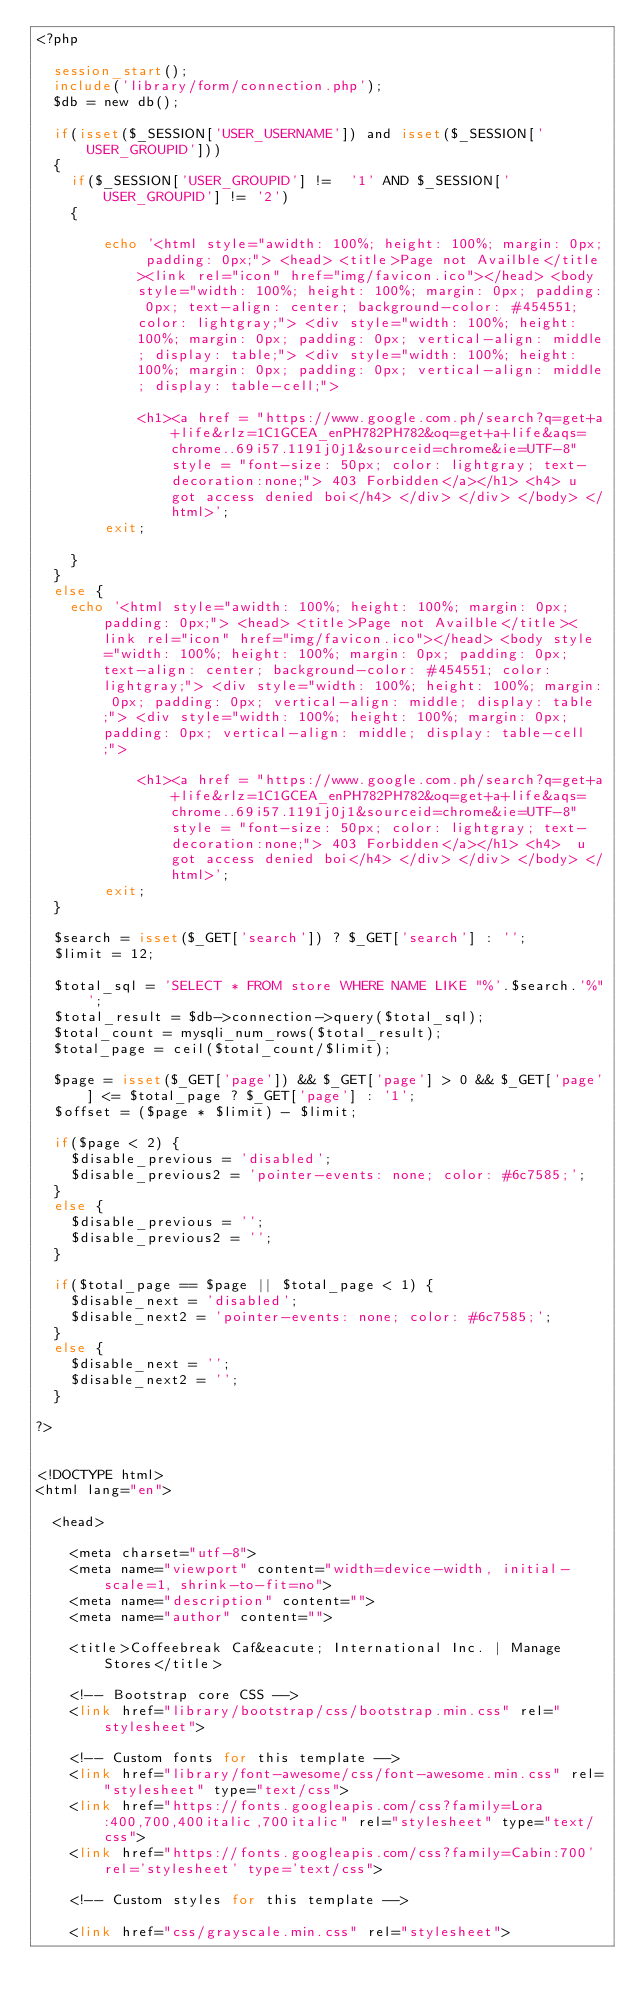Convert code to text. <code><loc_0><loc_0><loc_500><loc_500><_PHP_><?php
	
	session_start();
	include('library/form/connection.php');
	$db = new db();
	
	if(isset($_SESSION['USER_USERNAME']) and isset($_SESSION['USER_GROUPID']))
	{
		if($_SESSION['USER_GROUPID'] !=  '1' AND $_SESSION['USER_GROUPID'] != '2')
		{
			
        echo '<html style="awidth: 100%; height: 100%; margin: 0px; padding: 0px;"> <head> <title>Page not Availble</title><link rel="icon" href="img/favicon.ico"></head> <body style="width: 100%; height: 100%; margin: 0px; padding: 0px; text-align: center; background-color: #454551; color: lightgray;"> <div style="width: 100%; height: 100%; margin: 0px; padding: 0px; vertical-align: middle; display: table;"> <div style="width: 100%; height: 100%; margin: 0px; padding: 0px; vertical-align: middle; display: table-cell;"> 

            <h1><a href = "https://www.google.com.ph/search?q=get+a+life&rlz=1C1GCEA_enPH782PH782&oq=get+a+life&aqs=chrome..69i57.1191j0j1&sourceid=chrome&ie=UTF-8" style = "font-size: 50px; color: lightgray; text-decoration:none;"> 403 Forbidden</a></h1> <h4> u got access denied boi</h4> </div> </div> </body> </html>';
        exit;
   
		}
	}
	else {
		echo '<html style="awidth: 100%; height: 100%; margin: 0px; padding: 0px;"> <head> <title>Page not Availble</title><link rel="icon" href="img/favicon.ico"></head> <body style="width: 100%; height: 100%; margin: 0px; padding: 0px; text-align: center; background-color: #454551; color: lightgray;"> <div style="width: 100%; height: 100%; margin: 0px; padding: 0px; vertical-align: middle; display: table;"> <div style="width: 100%; height: 100%; margin: 0px; padding: 0px; vertical-align: middle; display: table-cell;"> 

            <h1><a href = "https://www.google.com.ph/search?q=get+a+life&rlz=1C1GCEA_enPH782PH782&oq=get+a+life&aqs=chrome..69i57.1191j0j1&sourceid=chrome&ie=UTF-8" style = "font-size: 50px; color: lightgray; text-decoration:none;"> 403 Forbidden</a></h1> <h4>  u got access denied boi</h4> </div> </div> </body> </html>';
        exit;
	}

	$search = isset($_GET['search']) ? $_GET['search'] : '';
	$limit = 12;

	$total_sql = 'SELECT * FROM store WHERE NAME LIKE "%'.$search.'%"';
	$total_result = $db->connection->query($total_sql);
	$total_count = mysqli_num_rows($total_result);
	$total_page = ceil($total_count/$limit);

	$page = isset($_GET['page']) && $_GET['page'] > 0 && $_GET['page'] <= $total_page ? $_GET['page'] : '1';
	$offset = ($page * $limit) - $limit;

	if($page < 2) {
		$disable_previous = 'disabled';
		$disable_previous2 = 'pointer-events: none; color: #6c7585;';
	}
	else {
		$disable_previous = '';
		$disable_previous2 = '';
	}

	if($total_page == $page || $total_page < 1) {
		$disable_next = 'disabled';
		$disable_next2 = 'pointer-events: none; color: #6c7585;';
	}
	else {
		$disable_next = '';
		$disable_next2 = '';
	}

?>


<!DOCTYPE html>
<html lang="en">

  <head>

    <meta charset="utf-8">
    <meta name="viewport" content="width=device-width, initial-scale=1, shrink-to-fit=no">
    <meta name="description" content="">
    <meta name="author" content="">

    <title>Coffeebreak Caf&eacute; International Inc. | Manage Stores</title>

    <!-- Bootstrap core CSS -->
    <link href="library/bootstrap/css/bootstrap.min.css" rel="stylesheet">
	 
    <!-- Custom fonts for this template -->
    <link href="library/font-awesome/css/font-awesome.min.css" rel="stylesheet" type="text/css">
    <link href="https://fonts.googleapis.com/css?family=Lora:400,700,400italic,700italic" rel="stylesheet" type="text/css">
    <link href="https://fonts.googleapis.com/css?family=Cabin:700' rel='stylesheet' type='text/css">

    <!-- Custom styles for this template -->
	
    <link href="css/grayscale.min.css" rel="stylesheet"></code> 